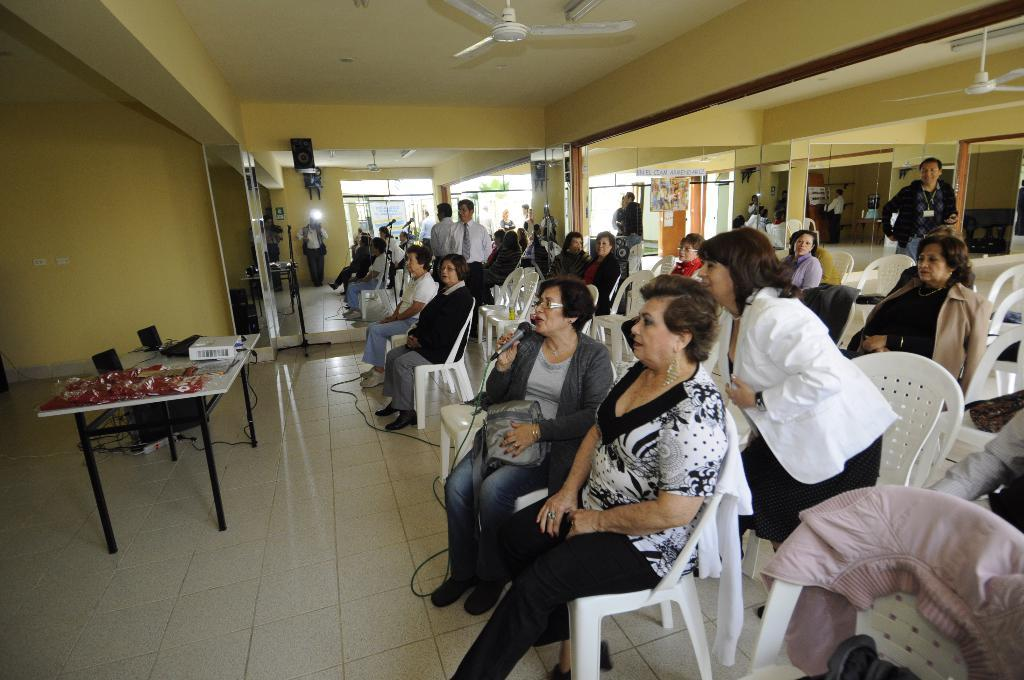What is one of the structures visible in the image? There is a wall in the image. What device can be seen in the image for circulating air? There is a fan in the image. What are the people in the image doing? They are sitting on chairs in the image. What piece of furniture is present in the image for placing objects? There is a table in the image. What is placed on the table for displaying visual content? There is a projector on the table. What electronic devices are present on the table for computing purposes? There are laptops on the table. What language is being spoken by the people in the image during the afternoon? The provided facts do not mention any language being spoken or the time of day, so we cannot determine the language or time from the image. 